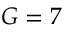<formula> <loc_0><loc_0><loc_500><loc_500>G = 7</formula> 